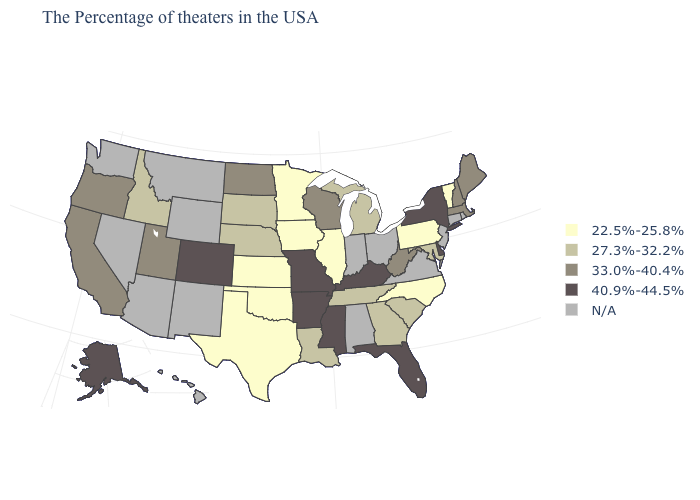Does North Carolina have the lowest value in the South?
Give a very brief answer. Yes. What is the value of Louisiana?
Write a very short answer. 27.3%-32.2%. Name the states that have a value in the range 40.9%-44.5%?
Short answer required. New York, Delaware, Florida, Kentucky, Mississippi, Missouri, Arkansas, Colorado, Alaska. What is the lowest value in the USA?
Quick response, please. 22.5%-25.8%. Name the states that have a value in the range N/A?
Short answer required. Rhode Island, Connecticut, New Jersey, Virginia, Ohio, Indiana, Alabama, Wyoming, New Mexico, Montana, Arizona, Nevada, Washington, Hawaii. What is the highest value in the MidWest ?
Be succinct. 40.9%-44.5%. Does Pennsylvania have the highest value in the USA?
Concise answer only. No. Does New York have the highest value in the Northeast?
Quick response, please. Yes. Name the states that have a value in the range 22.5%-25.8%?
Be succinct. Vermont, Pennsylvania, North Carolina, Illinois, Minnesota, Iowa, Kansas, Oklahoma, Texas. How many symbols are there in the legend?
Concise answer only. 5. What is the lowest value in states that border Michigan?
Short answer required. 33.0%-40.4%. Which states have the highest value in the USA?
Concise answer only. New York, Delaware, Florida, Kentucky, Mississippi, Missouri, Arkansas, Colorado, Alaska. Among the states that border Kentucky , which have the lowest value?
Quick response, please. Illinois. 